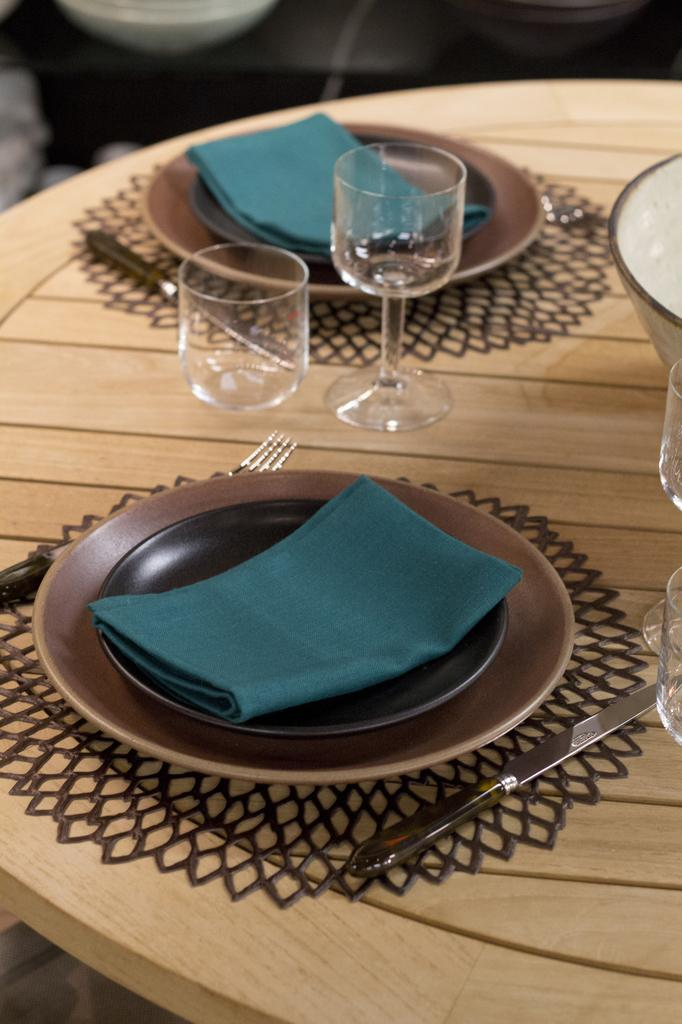What piece of furniture is present in the image? There is a table in the image. What items can be seen on the table? There are glasses, spoons, and plates on the table. What type of material is covering the table? There is a cloth on the table. How many eyes can be seen on the table in the image? There are no eyes present on the table in the image. What is the best way to carry water using the items on the table? There is no pail or container for carrying water among the items on the table. 